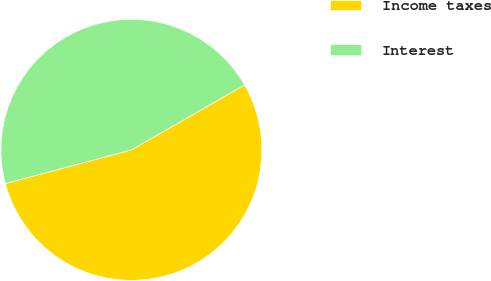Convert chart. <chart><loc_0><loc_0><loc_500><loc_500><pie_chart><fcel>Income taxes<fcel>Interest<nl><fcel>54.14%<fcel>45.86%<nl></chart> 